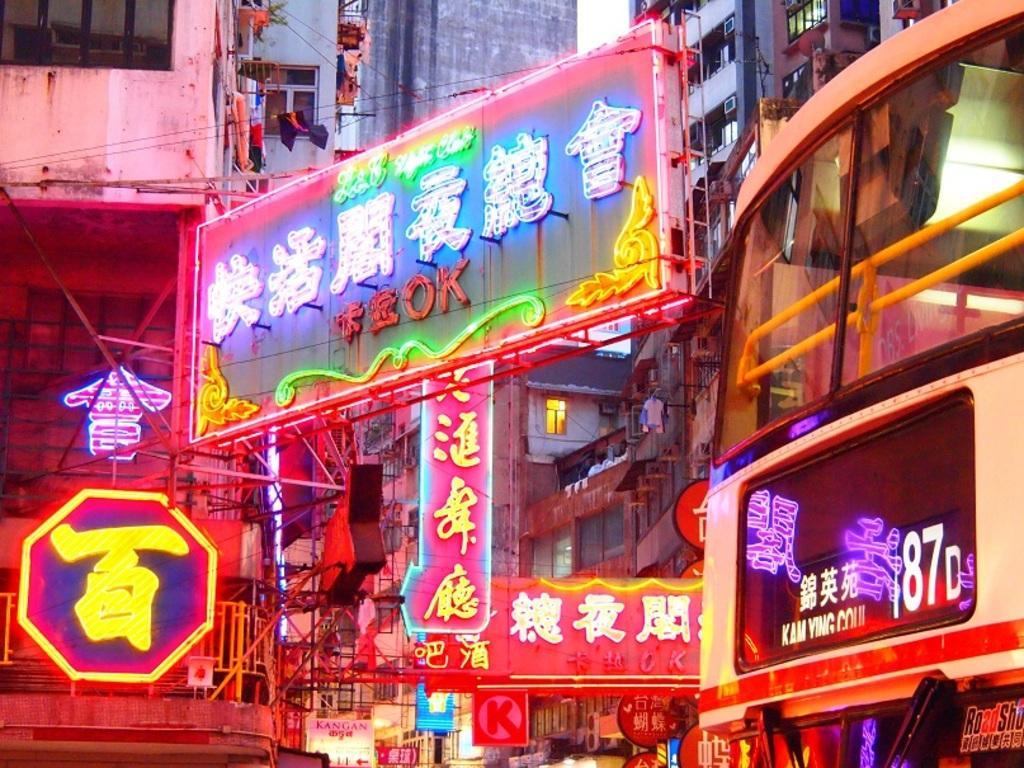Can you describe this image briefly? In this picture I can see there are a few buildings and it has windows and there are a few banners with lights and the sky is clear. 